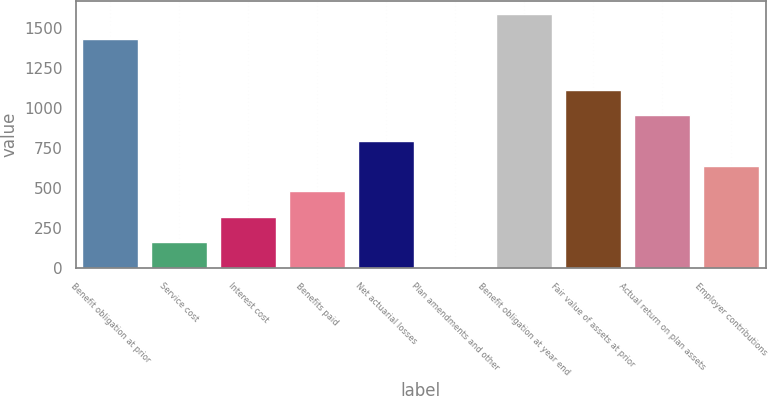<chart> <loc_0><loc_0><loc_500><loc_500><bar_chart><fcel>Benefit obligation at prior<fcel>Service cost<fcel>Interest cost<fcel>Benefits paid<fcel>Net actuarial losses<fcel>Plan amendments and other<fcel>Benefit obligation at year end<fcel>Fair value of assets at prior<fcel>Actual return on plan assets<fcel>Employer contributions<nl><fcel>1429.49<fcel>163.01<fcel>321.32<fcel>479.63<fcel>796.25<fcel>4.7<fcel>1587.8<fcel>1112.87<fcel>954.56<fcel>637.94<nl></chart> 